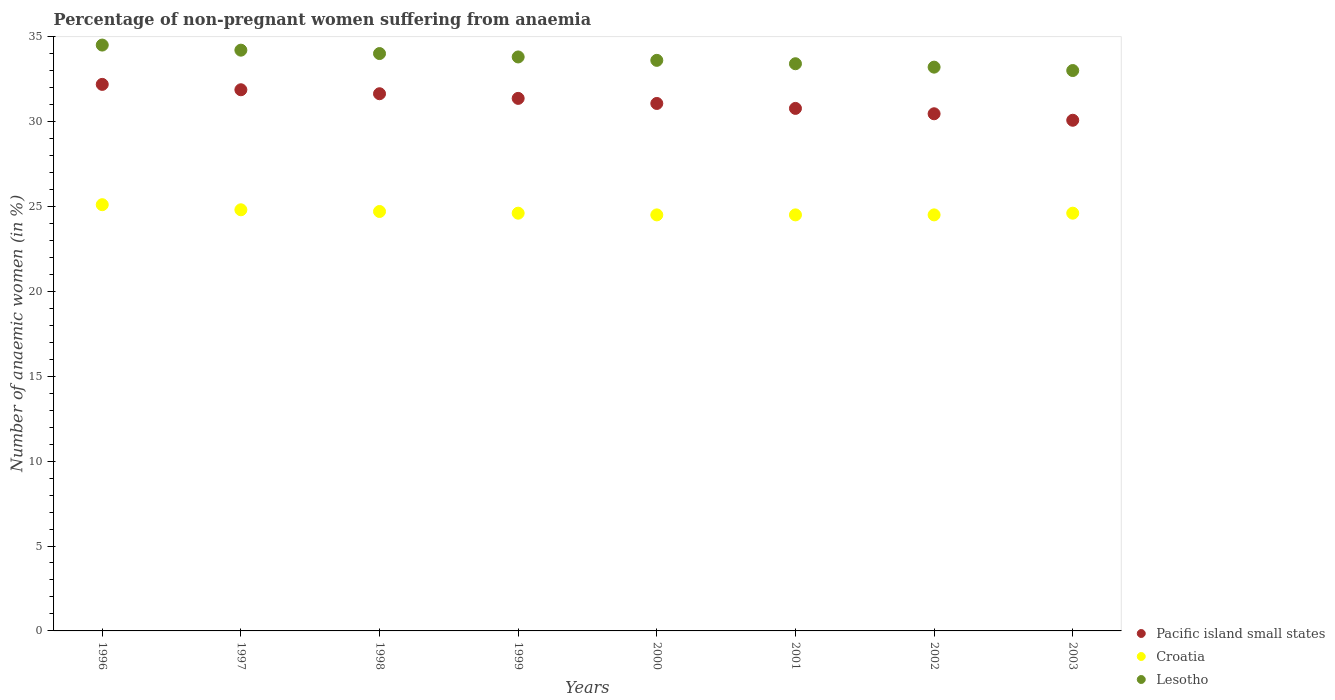Is the number of dotlines equal to the number of legend labels?
Provide a short and direct response. Yes. What is the percentage of non-pregnant women suffering from anaemia in Croatia in 2000?
Give a very brief answer. 24.5. Across all years, what is the maximum percentage of non-pregnant women suffering from anaemia in Pacific island small states?
Your response must be concise. 32.18. Across all years, what is the minimum percentage of non-pregnant women suffering from anaemia in Croatia?
Keep it short and to the point. 24.5. In which year was the percentage of non-pregnant women suffering from anaemia in Croatia minimum?
Offer a terse response. 2000. What is the total percentage of non-pregnant women suffering from anaemia in Croatia in the graph?
Make the answer very short. 197.3. What is the difference between the percentage of non-pregnant women suffering from anaemia in Croatia in 2003 and the percentage of non-pregnant women suffering from anaemia in Lesotho in 1997?
Provide a succinct answer. -9.6. What is the average percentage of non-pregnant women suffering from anaemia in Lesotho per year?
Keep it short and to the point. 33.71. In the year 2000, what is the difference between the percentage of non-pregnant women suffering from anaemia in Croatia and percentage of non-pregnant women suffering from anaemia in Pacific island small states?
Provide a short and direct response. -6.56. In how many years, is the percentage of non-pregnant women suffering from anaemia in Lesotho greater than 4 %?
Ensure brevity in your answer.  8. What is the ratio of the percentage of non-pregnant women suffering from anaemia in Croatia in 1996 to that in 2000?
Offer a terse response. 1.02. Is the percentage of non-pregnant women suffering from anaemia in Croatia in 1999 less than that in 2003?
Make the answer very short. No. What is the difference between the highest and the second highest percentage of non-pregnant women suffering from anaemia in Pacific island small states?
Keep it short and to the point. 0.32. What is the difference between the highest and the lowest percentage of non-pregnant women suffering from anaemia in Croatia?
Provide a short and direct response. 0.6. In how many years, is the percentage of non-pregnant women suffering from anaemia in Pacific island small states greater than the average percentage of non-pregnant women suffering from anaemia in Pacific island small states taken over all years?
Provide a short and direct response. 4. Is the sum of the percentage of non-pregnant women suffering from anaemia in Lesotho in 2001 and 2002 greater than the maximum percentage of non-pregnant women suffering from anaemia in Pacific island small states across all years?
Provide a succinct answer. Yes. Is it the case that in every year, the sum of the percentage of non-pregnant women suffering from anaemia in Lesotho and percentage of non-pregnant women suffering from anaemia in Pacific island small states  is greater than the percentage of non-pregnant women suffering from anaemia in Croatia?
Your answer should be compact. Yes. Is the percentage of non-pregnant women suffering from anaemia in Croatia strictly greater than the percentage of non-pregnant women suffering from anaemia in Pacific island small states over the years?
Provide a short and direct response. No. How many dotlines are there?
Ensure brevity in your answer.  3. How many years are there in the graph?
Your response must be concise. 8. Are the values on the major ticks of Y-axis written in scientific E-notation?
Your answer should be very brief. No. How many legend labels are there?
Offer a terse response. 3. What is the title of the graph?
Give a very brief answer. Percentage of non-pregnant women suffering from anaemia. Does "Guyana" appear as one of the legend labels in the graph?
Your answer should be compact. No. What is the label or title of the Y-axis?
Provide a succinct answer. Number of anaemic women (in %). What is the Number of anaemic women (in %) of Pacific island small states in 1996?
Offer a very short reply. 32.18. What is the Number of anaemic women (in %) in Croatia in 1996?
Offer a terse response. 25.1. What is the Number of anaemic women (in %) in Lesotho in 1996?
Ensure brevity in your answer.  34.5. What is the Number of anaemic women (in %) in Pacific island small states in 1997?
Ensure brevity in your answer.  31.87. What is the Number of anaemic women (in %) of Croatia in 1997?
Make the answer very short. 24.8. What is the Number of anaemic women (in %) of Lesotho in 1997?
Offer a terse response. 34.2. What is the Number of anaemic women (in %) in Pacific island small states in 1998?
Make the answer very short. 31.63. What is the Number of anaemic women (in %) of Croatia in 1998?
Provide a succinct answer. 24.7. What is the Number of anaemic women (in %) in Pacific island small states in 1999?
Offer a terse response. 31.36. What is the Number of anaemic women (in %) of Croatia in 1999?
Make the answer very short. 24.6. What is the Number of anaemic women (in %) in Lesotho in 1999?
Provide a short and direct response. 33.8. What is the Number of anaemic women (in %) in Pacific island small states in 2000?
Offer a very short reply. 31.06. What is the Number of anaemic women (in %) in Croatia in 2000?
Make the answer very short. 24.5. What is the Number of anaemic women (in %) of Lesotho in 2000?
Your answer should be compact. 33.6. What is the Number of anaemic women (in %) in Pacific island small states in 2001?
Offer a terse response. 30.77. What is the Number of anaemic women (in %) of Croatia in 2001?
Provide a succinct answer. 24.5. What is the Number of anaemic women (in %) in Lesotho in 2001?
Provide a succinct answer. 33.4. What is the Number of anaemic women (in %) of Pacific island small states in 2002?
Offer a terse response. 30.45. What is the Number of anaemic women (in %) in Croatia in 2002?
Your answer should be very brief. 24.5. What is the Number of anaemic women (in %) in Lesotho in 2002?
Give a very brief answer. 33.2. What is the Number of anaemic women (in %) in Pacific island small states in 2003?
Provide a succinct answer. 30.07. What is the Number of anaemic women (in %) in Croatia in 2003?
Your answer should be compact. 24.6. What is the Number of anaemic women (in %) in Lesotho in 2003?
Your answer should be compact. 33. Across all years, what is the maximum Number of anaemic women (in %) in Pacific island small states?
Your response must be concise. 32.18. Across all years, what is the maximum Number of anaemic women (in %) in Croatia?
Provide a succinct answer. 25.1. Across all years, what is the maximum Number of anaemic women (in %) in Lesotho?
Keep it short and to the point. 34.5. Across all years, what is the minimum Number of anaemic women (in %) of Pacific island small states?
Your answer should be compact. 30.07. Across all years, what is the minimum Number of anaemic women (in %) in Lesotho?
Provide a succinct answer. 33. What is the total Number of anaemic women (in %) of Pacific island small states in the graph?
Offer a very short reply. 249.4. What is the total Number of anaemic women (in %) of Croatia in the graph?
Your answer should be compact. 197.3. What is the total Number of anaemic women (in %) in Lesotho in the graph?
Ensure brevity in your answer.  269.7. What is the difference between the Number of anaemic women (in %) of Pacific island small states in 1996 and that in 1997?
Keep it short and to the point. 0.32. What is the difference between the Number of anaemic women (in %) of Croatia in 1996 and that in 1997?
Offer a very short reply. 0.3. What is the difference between the Number of anaemic women (in %) of Pacific island small states in 1996 and that in 1998?
Your answer should be compact. 0.55. What is the difference between the Number of anaemic women (in %) of Croatia in 1996 and that in 1998?
Your answer should be very brief. 0.4. What is the difference between the Number of anaemic women (in %) in Pacific island small states in 1996 and that in 1999?
Provide a short and direct response. 0.82. What is the difference between the Number of anaemic women (in %) in Lesotho in 1996 and that in 1999?
Provide a short and direct response. 0.7. What is the difference between the Number of anaemic women (in %) of Pacific island small states in 1996 and that in 2000?
Make the answer very short. 1.12. What is the difference between the Number of anaemic women (in %) in Pacific island small states in 1996 and that in 2001?
Your response must be concise. 1.41. What is the difference between the Number of anaemic women (in %) of Lesotho in 1996 and that in 2001?
Keep it short and to the point. 1.1. What is the difference between the Number of anaemic women (in %) of Pacific island small states in 1996 and that in 2002?
Offer a terse response. 1.73. What is the difference between the Number of anaemic women (in %) of Croatia in 1996 and that in 2002?
Ensure brevity in your answer.  0.6. What is the difference between the Number of anaemic women (in %) of Lesotho in 1996 and that in 2002?
Keep it short and to the point. 1.3. What is the difference between the Number of anaemic women (in %) in Pacific island small states in 1996 and that in 2003?
Offer a terse response. 2.11. What is the difference between the Number of anaemic women (in %) of Pacific island small states in 1997 and that in 1998?
Make the answer very short. 0.23. What is the difference between the Number of anaemic women (in %) of Pacific island small states in 1997 and that in 1999?
Ensure brevity in your answer.  0.51. What is the difference between the Number of anaemic women (in %) in Croatia in 1997 and that in 1999?
Your response must be concise. 0.2. What is the difference between the Number of anaemic women (in %) of Pacific island small states in 1997 and that in 2000?
Keep it short and to the point. 0.81. What is the difference between the Number of anaemic women (in %) in Croatia in 1997 and that in 2000?
Your answer should be very brief. 0.3. What is the difference between the Number of anaemic women (in %) in Lesotho in 1997 and that in 2000?
Provide a succinct answer. 0.6. What is the difference between the Number of anaemic women (in %) in Pacific island small states in 1997 and that in 2001?
Your answer should be very brief. 1.1. What is the difference between the Number of anaemic women (in %) in Croatia in 1997 and that in 2001?
Offer a terse response. 0.3. What is the difference between the Number of anaemic women (in %) in Lesotho in 1997 and that in 2001?
Keep it short and to the point. 0.8. What is the difference between the Number of anaemic women (in %) in Pacific island small states in 1997 and that in 2002?
Make the answer very short. 1.41. What is the difference between the Number of anaemic women (in %) of Lesotho in 1997 and that in 2002?
Keep it short and to the point. 1. What is the difference between the Number of anaemic women (in %) in Pacific island small states in 1997 and that in 2003?
Your answer should be very brief. 1.8. What is the difference between the Number of anaemic women (in %) of Croatia in 1997 and that in 2003?
Provide a succinct answer. 0.2. What is the difference between the Number of anaemic women (in %) of Pacific island small states in 1998 and that in 1999?
Make the answer very short. 0.27. What is the difference between the Number of anaemic women (in %) in Pacific island small states in 1998 and that in 2000?
Your response must be concise. 0.57. What is the difference between the Number of anaemic women (in %) in Lesotho in 1998 and that in 2000?
Your response must be concise. 0.4. What is the difference between the Number of anaemic women (in %) in Pacific island small states in 1998 and that in 2001?
Offer a very short reply. 0.86. What is the difference between the Number of anaemic women (in %) of Pacific island small states in 1998 and that in 2002?
Offer a terse response. 1.18. What is the difference between the Number of anaemic women (in %) in Croatia in 1998 and that in 2002?
Your response must be concise. 0.2. What is the difference between the Number of anaemic women (in %) of Pacific island small states in 1998 and that in 2003?
Provide a succinct answer. 1.56. What is the difference between the Number of anaemic women (in %) of Pacific island small states in 1999 and that in 2000?
Provide a short and direct response. 0.3. What is the difference between the Number of anaemic women (in %) in Croatia in 1999 and that in 2000?
Provide a short and direct response. 0.1. What is the difference between the Number of anaemic women (in %) of Pacific island small states in 1999 and that in 2001?
Give a very brief answer. 0.59. What is the difference between the Number of anaemic women (in %) in Croatia in 1999 and that in 2001?
Offer a very short reply. 0.1. What is the difference between the Number of anaemic women (in %) of Pacific island small states in 1999 and that in 2002?
Offer a terse response. 0.91. What is the difference between the Number of anaemic women (in %) in Lesotho in 1999 and that in 2002?
Give a very brief answer. 0.6. What is the difference between the Number of anaemic women (in %) in Pacific island small states in 1999 and that in 2003?
Offer a terse response. 1.29. What is the difference between the Number of anaemic women (in %) of Croatia in 1999 and that in 2003?
Offer a very short reply. 0. What is the difference between the Number of anaemic women (in %) in Pacific island small states in 2000 and that in 2001?
Your answer should be compact. 0.29. What is the difference between the Number of anaemic women (in %) in Pacific island small states in 2000 and that in 2002?
Offer a very short reply. 0.61. What is the difference between the Number of anaemic women (in %) of Croatia in 2000 and that in 2002?
Offer a terse response. 0. What is the difference between the Number of anaemic women (in %) in Croatia in 2000 and that in 2003?
Your answer should be compact. -0.1. What is the difference between the Number of anaemic women (in %) in Pacific island small states in 2001 and that in 2002?
Keep it short and to the point. 0.32. What is the difference between the Number of anaemic women (in %) of Lesotho in 2001 and that in 2002?
Make the answer very short. 0.2. What is the difference between the Number of anaemic women (in %) in Pacific island small states in 2001 and that in 2003?
Ensure brevity in your answer.  0.7. What is the difference between the Number of anaemic women (in %) in Croatia in 2001 and that in 2003?
Offer a terse response. -0.1. What is the difference between the Number of anaemic women (in %) of Pacific island small states in 2002 and that in 2003?
Provide a succinct answer. 0.38. What is the difference between the Number of anaemic women (in %) of Croatia in 2002 and that in 2003?
Give a very brief answer. -0.1. What is the difference between the Number of anaemic women (in %) in Lesotho in 2002 and that in 2003?
Keep it short and to the point. 0.2. What is the difference between the Number of anaemic women (in %) in Pacific island small states in 1996 and the Number of anaemic women (in %) in Croatia in 1997?
Ensure brevity in your answer.  7.38. What is the difference between the Number of anaemic women (in %) of Pacific island small states in 1996 and the Number of anaemic women (in %) of Lesotho in 1997?
Offer a very short reply. -2.02. What is the difference between the Number of anaemic women (in %) in Pacific island small states in 1996 and the Number of anaemic women (in %) in Croatia in 1998?
Your answer should be very brief. 7.48. What is the difference between the Number of anaemic women (in %) in Pacific island small states in 1996 and the Number of anaemic women (in %) in Lesotho in 1998?
Provide a short and direct response. -1.82. What is the difference between the Number of anaemic women (in %) of Croatia in 1996 and the Number of anaemic women (in %) of Lesotho in 1998?
Offer a terse response. -8.9. What is the difference between the Number of anaemic women (in %) of Pacific island small states in 1996 and the Number of anaemic women (in %) of Croatia in 1999?
Your response must be concise. 7.58. What is the difference between the Number of anaemic women (in %) in Pacific island small states in 1996 and the Number of anaemic women (in %) in Lesotho in 1999?
Provide a short and direct response. -1.62. What is the difference between the Number of anaemic women (in %) of Croatia in 1996 and the Number of anaemic women (in %) of Lesotho in 1999?
Offer a terse response. -8.7. What is the difference between the Number of anaemic women (in %) of Pacific island small states in 1996 and the Number of anaemic women (in %) of Croatia in 2000?
Provide a short and direct response. 7.68. What is the difference between the Number of anaemic women (in %) in Pacific island small states in 1996 and the Number of anaemic women (in %) in Lesotho in 2000?
Give a very brief answer. -1.42. What is the difference between the Number of anaemic women (in %) in Croatia in 1996 and the Number of anaemic women (in %) in Lesotho in 2000?
Ensure brevity in your answer.  -8.5. What is the difference between the Number of anaemic women (in %) of Pacific island small states in 1996 and the Number of anaemic women (in %) of Croatia in 2001?
Give a very brief answer. 7.68. What is the difference between the Number of anaemic women (in %) in Pacific island small states in 1996 and the Number of anaemic women (in %) in Lesotho in 2001?
Give a very brief answer. -1.22. What is the difference between the Number of anaemic women (in %) of Pacific island small states in 1996 and the Number of anaemic women (in %) of Croatia in 2002?
Your answer should be compact. 7.68. What is the difference between the Number of anaemic women (in %) in Pacific island small states in 1996 and the Number of anaemic women (in %) in Lesotho in 2002?
Offer a terse response. -1.02. What is the difference between the Number of anaemic women (in %) in Croatia in 1996 and the Number of anaemic women (in %) in Lesotho in 2002?
Provide a short and direct response. -8.1. What is the difference between the Number of anaemic women (in %) of Pacific island small states in 1996 and the Number of anaemic women (in %) of Croatia in 2003?
Your answer should be very brief. 7.58. What is the difference between the Number of anaemic women (in %) in Pacific island small states in 1996 and the Number of anaemic women (in %) in Lesotho in 2003?
Make the answer very short. -0.82. What is the difference between the Number of anaemic women (in %) of Pacific island small states in 1997 and the Number of anaemic women (in %) of Croatia in 1998?
Ensure brevity in your answer.  7.17. What is the difference between the Number of anaemic women (in %) in Pacific island small states in 1997 and the Number of anaemic women (in %) in Lesotho in 1998?
Your response must be concise. -2.13. What is the difference between the Number of anaemic women (in %) of Croatia in 1997 and the Number of anaemic women (in %) of Lesotho in 1998?
Offer a very short reply. -9.2. What is the difference between the Number of anaemic women (in %) in Pacific island small states in 1997 and the Number of anaemic women (in %) in Croatia in 1999?
Offer a very short reply. 7.27. What is the difference between the Number of anaemic women (in %) of Pacific island small states in 1997 and the Number of anaemic women (in %) of Lesotho in 1999?
Ensure brevity in your answer.  -1.93. What is the difference between the Number of anaemic women (in %) of Croatia in 1997 and the Number of anaemic women (in %) of Lesotho in 1999?
Keep it short and to the point. -9. What is the difference between the Number of anaemic women (in %) in Pacific island small states in 1997 and the Number of anaemic women (in %) in Croatia in 2000?
Provide a succinct answer. 7.37. What is the difference between the Number of anaemic women (in %) in Pacific island small states in 1997 and the Number of anaemic women (in %) in Lesotho in 2000?
Provide a succinct answer. -1.73. What is the difference between the Number of anaemic women (in %) of Pacific island small states in 1997 and the Number of anaemic women (in %) of Croatia in 2001?
Provide a short and direct response. 7.37. What is the difference between the Number of anaemic women (in %) in Pacific island small states in 1997 and the Number of anaemic women (in %) in Lesotho in 2001?
Offer a very short reply. -1.53. What is the difference between the Number of anaemic women (in %) in Pacific island small states in 1997 and the Number of anaemic women (in %) in Croatia in 2002?
Keep it short and to the point. 7.37. What is the difference between the Number of anaemic women (in %) of Pacific island small states in 1997 and the Number of anaemic women (in %) of Lesotho in 2002?
Provide a succinct answer. -1.33. What is the difference between the Number of anaemic women (in %) of Pacific island small states in 1997 and the Number of anaemic women (in %) of Croatia in 2003?
Offer a very short reply. 7.27. What is the difference between the Number of anaemic women (in %) in Pacific island small states in 1997 and the Number of anaemic women (in %) in Lesotho in 2003?
Your answer should be very brief. -1.13. What is the difference between the Number of anaemic women (in %) in Croatia in 1997 and the Number of anaemic women (in %) in Lesotho in 2003?
Make the answer very short. -8.2. What is the difference between the Number of anaemic women (in %) of Pacific island small states in 1998 and the Number of anaemic women (in %) of Croatia in 1999?
Offer a very short reply. 7.03. What is the difference between the Number of anaemic women (in %) of Pacific island small states in 1998 and the Number of anaemic women (in %) of Lesotho in 1999?
Your answer should be compact. -2.17. What is the difference between the Number of anaemic women (in %) of Croatia in 1998 and the Number of anaemic women (in %) of Lesotho in 1999?
Your answer should be compact. -9.1. What is the difference between the Number of anaemic women (in %) in Pacific island small states in 1998 and the Number of anaemic women (in %) in Croatia in 2000?
Provide a succinct answer. 7.13. What is the difference between the Number of anaemic women (in %) in Pacific island small states in 1998 and the Number of anaemic women (in %) in Lesotho in 2000?
Give a very brief answer. -1.97. What is the difference between the Number of anaemic women (in %) of Pacific island small states in 1998 and the Number of anaemic women (in %) of Croatia in 2001?
Your answer should be very brief. 7.13. What is the difference between the Number of anaemic women (in %) in Pacific island small states in 1998 and the Number of anaemic women (in %) in Lesotho in 2001?
Offer a very short reply. -1.77. What is the difference between the Number of anaemic women (in %) of Pacific island small states in 1998 and the Number of anaemic women (in %) of Croatia in 2002?
Provide a succinct answer. 7.13. What is the difference between the Number of anaemic women (in %) of Pacific island small states in 1998 and the Number of anaemic women (in %) of Lesotho in 2002?
Give a very brief answer. -1.57. What is the difference between the Number of anaemic women (in %) of Croatia in 1998 and the Number of anaemic women (in %) of Lesotho in 2002?
Your answer should be very brief. -8.5. What is the difference between the Number of anaemic women (in %) of Pacific island small states in 1998 and the Number of anaemic women (in %) of Croatia in 2003?
Ensure brevity in your answer.  7.03. What is the difference between the Number of anaemic women (in %) of Pacific island small states in 1998 and the Number of anaemic women (in %) of Lesotho in 2003?
Provide a short and direct response. -1.37. What is the difference between the Number of anaemic women (in %) of Croatia in 1998 and the Number of anaemic women (in %) of Lesotho in 2003?
Your response must be concise. -8.3. What is the difference between the Number of anaemic women (in %) of Pacific island small states in 1999 and the Number of anaemic women (in %) of Croatia in 2000?
Provide a succinct answer. 6.86. What is the difference between the Number of anaemic women (in %) of Pacific island small states in 1999 and the Number of anaemic women (in %) of Lesotho in 2000?
Your answer should be compact. -2.24. What is the difference between the Number of anaemic women (in %) of Pacific island small states in 1999 and the Number of anaemic women (in %) of Croatia in 2001?
Provide a short and direct response. 6.86. What is the difference between the Number of anaemic women (in %) of Pacific island small states in 1999 and the Number of anaemic women (in %) of Lesotho in 2001?
Provide a succinct answer. -2.04. What is the difference between the Number of anaemic women (in %) in Croatia in 1999 and the Number of anaemic women (in %) in Lesotho in 2001?
Provide a succinct answer. -8.8. What is the difference between the Number of anaemic women (in %) of Pacific island small states in 1999 and the Number of anaemic women (in %) of Croatia in 2002?
Offer a terse response. 6.86. What is the difference between the Number of anaemic women (in %) of Pacific island small states in 1999 and the Number of anaemic women (in %) of Lesotho in 2002?
Make the answer very short. -1.84. What is the difference between the Number of anaemic women (in %) of Croatia in 1999 and the Number of anaemic women (in %) of Lesotho in 2002?
Ensure brevity in your answer.  -8.6. What is the difference between the Number of anaemic women (in %) of Pacific island small states in 1999 and the Number of anaemic women (in %) of Croatia in 2003?
Offer a very short reply. 6.76. What is the difference between the Number of anaemic women (in %) of Pacific island small states in 1999 and the Number of anaemic women (in %) of Lesotho in 2003?
Your answer should be compact. -1.64. What is the difference between the Number of anaemic women (in %) of Pacific island small states in 2000 and the Number of anaemic women (in %) of Croatia in 2001?
Make the answer very short. 6.56. What is the difference between the Number of anaemic women (in %) of Pacific island small states in 2000 and the Number of anaemic women (in %) of Lesotho in 2001?
Provide a short and direct response. -2.34. What is the difference between the Number of anaemic women (in %) of Pacific island small states in 2000 and the Number of anaemic women (in %) of Croatia in 2002?
Your answer should be very brief. 6.56. What is the difference between the Number of anaemic women (in %) of Pacific island small states in 2000 and the Number of anaemic women (in %) of Lesotho in 2002?
Ensure brevity in your answer.  -2.14. What is the difference between the Number of anaemic women (in %) in Pacific island small states in 2000 and the Number of anaemic women (in %) in Croatia in 2003?
Make the answer very short. 6.46. What is the difference between the Number of anaemic women (in %) of Pacific island small states in 2000 and the Number of anaemic women (in %) of Lesotho in 2003?
Ensure brevity in your answer.  -1.94. What is the difference between the Number of anaemic women (in %) of Pacific island small states in 2001 and the Number of anaemic women (in %) of Croatia in 2002?
Ensure brevity in your answer.  6.27. What is the difference between the Number of anaemic women (in %) in Pacific island small states in 2001 and the Number of anaemic women (in %) in Lesotho in 2002?
Give a very brief answer. -2.43. What is the difference between the Number of anaemic women (in %) of Pacific island small states in 2001 and the Number of anaemic women (in %) of Croatia in 2003?
Your answer should be very brief. 6.17. What is the difference between the Number of anaemic women (in %) in Pacific island small states in 2001 and the Number of anaemic women (in %) in Lesotho in 2003?
Ensure brevity in your answer.  -2.23. What is the difference between the Number of anaemic women (in %) of Pacific island small states in 2002 and the Number of anaemic women (in %) of Croatia in 2003?
Your answer should be compact. 5.85. What is the difference between the Number of anaemic women (in %) in Pacific island small states in 2002 and the Number of anaemic women (in %) in Lesotho in 2003?
Your answer should be compact. -2.55. What is the average Number of anaemic women (in %) in Pacific island small states per year?
Provide a succinct answer. 31.18. What is the average Number of anaemic women (in %) of Croatia per year?
Offer a very short reply. 24.66. What is the average Number of anaemic women (in %) in Lesotho per year?
Your response must be concise. 33.71. In the year 1996, what is the difference between the Number of anaemic women (in %) in Pacific island small states and Number of anaemic women (in %) in Croatia?
Make the answer very short. 7.08. In the year 1996, what is the difference between the Number of anaemic women (in %) of Pacific island small states and Number of anaemic women (in %) of Lesotho?
Ensure brevity in your answer.  -2.32. In the year 1996, what is the difference between the Number of anaemic women (in %) of Croatia and Number of anaemic women (in %) of Lesotho?
Your answer should be very brief. -9.4. In the year 1997, what is the difference between the Number of anaemic women (in %) in Pacific island small states and Number of anaemic women (in %) in Croatia?
Your answer should be very brief. 7.07. In the year 1997, what is the difference between the Number of anaemic women (in %) of Pacific island small states and Number of anaemic women (in %) of Lesotho?
Offer a terse response. -2.33. In the year 1998, what is the difference between the Number of anaemic women (in %) in Pacific island small states and Number of anaemic women (in %) in Croatia?
Ensure brevity in your answer.  6.93. In the year 1998, what is the difference between the Number of anaemic women (in %) in Pacific island small states and Number of anaemic women (in %) in Lesotho?
Make the answer very short. -2.37. In the year 1999, what is the difference between the Number of anaemic women (in %) in Pacific island small states and Number of anaemic women (in %) in Croatia?
Your response must be concise. 6.76. In the year 1999, what is the difference between the Number of anaemic women (in %) in Pacific island small states and Number of anaemic women (in %) in Lesotho?
Offer a very short reply. -2.44. In the year 1999, what is the difference between the Number of anaemic women (in %) of Croatia and Number of anaemic women (in %) of Lesotho?
Your answer should be very brief. -9.2. In the year 2000, what is the difference between the Number of anaemic women (in %) in Pacific island small states and Number of anaemic women (in %) in Croatia?
Your answer should be compact. 6.56. In the year 2000, what is the difference between the Number of anaemic women (in %) of Pacific island small states and Number of anaemic women (in %) of Lesotho?
Ensure brevity in your answer.  -2.54. In the year 2000, what is the difference between the Number of anaemic women (in %) in Croatia and Number of anaemic women (in %) in Lesotho?
Offer a terse response. -9.1. In the year 2001, what is the difference between the Number of anaemic women (in %) of Pacific island small states and Number of anaemic women (in %) of Croatia?
Give a very brief answer. 6.27. In the year 2001, what is the difference between the Number of anaemic women (in %) of Pacific island small states and Number of anaemic women (in %) of Lesotho?
Ensure brevity in your answer.  -2.63. In the year 2002, what is the difference between the Number of anaemic women (in %) in Pacific island small states and Number of anaemic women (in %) in Croatia?
Keep it short and to the point. 5.95. In the year 2002, what is the difference between the Number of anaemic women (in %) in Pacific island small states and Number of anaemic women (in %) in Lesotho?
Your response must be concise. -2.75. In the year 2002, what is the difference between the Number of anaemic women (in %) of Croatia and Number of anaemic women (in %) of Lesotho?
Offer a very short reply. -8.7. In the year 2003, what is the difference between the Number of anaemic women (in %) of Pacific island small states and Number of anaemic women (in %) of Croatia?
Give a very brief answer. 5.47. In the year 2003, what is the difference between the Number of anaemic women (in %) of Pacific island small states and Number of anaemic women (in %) of Lesotho?
Your answer should be very brief. -2.93. What is the ratio of the Number of anaemic women (in %) of Pacific island small states in 1996 to that in 1997?
Offer a terse response. 1.01. What is the ratio of the Number of anaemic women (in %) of Croatia in 1996 to that in 1997?
Make the answer very short. 1.01. What is the ratio of the Number of anaemic women (in %) of Lesotho in 1996 to that in 1997?
Make the answer very short. 1.01. What is the ratio of the Number of anaemic women (in %) in Pacific island small states in 1996 to that in 1998?
Your answer should be very brief. 1.02. What is the ratio of the Number of anaemic women (in %) in Croatia in 1996 to that in 1998?
Ensure brevity in your answer.  1.02. What is the ratio of the Number of anaemic women (in %) of Lesotho in 1996 to that in 1998?
Offer a very short reply. 1.01. What is the ratio of the Number of anaemic women (in %) in Pacific island small states in 1996 to that in 1999?
Provide a short and direct response. 1.03. What is the ratio of the Number of anaemic women (in %) of Croatia in 1996 to that in 1999?
Your response must be concise. 1.02. What is the ratio of the Number of anaemic women (in %) in Lesotho in 1996 to that in 1999?
Offer a very short reply. 1.02. What is the ratio of the Number of anaemic women (in %) in Pacific island small states in 1996 to that in 2000?
Provide a short and direct response. 1.04. What is the ratio of the Number of anaemic women (in %) in Croatia in 1996 to that in 2000?
Your response must be concise. 1.02. What is the ratio of the Number of anaemic women (in %) in Lesotho in 1996 to that in 2000?
Your response must be concise. 1.03. What is the ratio of the Number of anaemic women (in %) of Pacific island small states in 1996 to that in 2001?
Offer a very short reply. 1.05. What is the ratio of the Number of anaemic women (in %) of Croatia in 1996 to that in 2001?
Keep it short and to the point. 1.02. What is the ratio of the Number of anaemic women (in %) of Lesotho in 1996 to that in 2001?
Give a very brief answer. 1.03. What is the ratio of the Number of anaemic women (in %) of Pacific island small states in 1996 to that in 2002?
Give a very brief answer. 1.06. What is the ratio of the Number of anaemic women (in %) in Croatia in 1996 to that in 2002?
Offer a very short reply. 1.02. What is the ratio of the Number of anaemic women (in %) of Lesotho in 1996 to that in 2002?
Offer a very short reply. 1.04. What is the ratio of the Number of anaemic women (in %) of Pacific island small states in 1996 to that in 2003?
Give a very brief answer. 1.07. What is the ratio of the Number of anaemic women (in %) in Croatia in 1996 to that in 2003?
Your response must be concise. 1.02. What is the ratio of the Number of anaemic women (in %) in Lesotho in 1996 to that in 2003?
Make the answer very short. 1.05. What is the ratio of the Number of anaemic women (in %) of Pacific island small states in 1997 to that in 1998?
Offer a terse response. 1.01. What is the ratio of the Number of anaemic women (in %) in Lesotho in 1997 to that in 1998?
Offer a very short reply. 1.01. What is the ratio of the Number of anaemic women (in %) in Pacific island small states in 1997 to that in 1999?
Give a very brief answer. 1.02. What is the ratio of the Number of anaemic women (in %) of Lesotho in 1997 to that in 1999?
Give a very brief answer. 1.01. What is the ratio of the Number of anaemic women (in %) of Croatia in 1997 to that in 2000?
Your answer should be very brief. 1.01. What is the ratio of the Number of anaemic women (in %) of Lesotho in 1997 to that in 2000?
Your answer should be compact. 1.02. What is the ratio of the Number of anaemic women (in %) of Pacific island small states in 1997 to that in 2001?
Keep it short and to the point. 1.04. What is the ratio of the Number of anaemic women (in %) in Croatia in 1997 to that in 2001?
Give a very brief answer. 1.01. What is the ratio of the Number of anaemic women (in %) of Lesotho in 1997 to that in 2001?
Make the answer very short. 1.02. What is the ratio of the Number of anaemic women (in %) in Pacific island small states in 1997 to that in 2002?
Give a very brief answer. 1.05. What is the ratio of the Number of anaemic women (in %) of Croatia in 1997 to that in 2002?
Offer a very short reply. 1.01. What is the ratio of the Number of anaemic women (in %) in Lesotho in 1997 to that in 2002?
Provide a succinct answer. 1.03. What is the ratio of the Number of anaemic women (in %) of Pacific island small states in 1997 to that in 2003?
Make the answer very short. 1.06. What is the ratio of the Number of anaemic women (in %) of Croatia in 1997 to that in 2003?
Offer a terse response. 1.01. What is the ratio of the Number of anaemic women (in %) of Lesotho in 1997 to that in 2003?
Your answer should be compact. 1.04. What is the ratio of the Number of anaemic women (in %) of Pacific island small states in 1998 to that in 1999?
Make the answer very short. 1.01. What is the ratio of the Number of anaemic women (in %) of Lesotho in 1998 to that in 1999?
Your answer should be very brief. 1.01. What is the ratio of the Number of anaemic women (in %) in Pacific island small states in 1998 to that in 2000?
Your answer should be compact. 1.02. What is the ratio of the Number of anaemic women (in %) of Croatia in 1998 to that in 2000?
Provide a short and direct response. 1.01. What is the ratio of the Number of anaemic women (in %) of Lesotho in 1998 to that in 2000?
Provide a short and direct response. 1.01. What is the ratio of the Number of anaemic women (in %) in Pacific island small states in 1998 to that in 2001?
Make the answer very short. 1.03. What is the ratio of the Number of anaemic women (in %) in Croatia in 1998 to that in 2001?
Your answer should be very brief. 1.01. What is the ratio of the Number of anaemic women (in %) in Lesotho in 1998 to that in 2001?
Offer a very short reply. 1.02. What is the ratio of the Number of anaemic women (in %) of Pacific island small states in 1998 to that in 2002?
Your response must be concise. 1.04. What is the ratio of the Number of anaemic women (in %) of Croatia in 1998 to that in 2002?
Provide a succinct answer. 1.01. What is the ratio of the Number of anaemic women (in %) of Lesotho in 1998 to that in 2002?
Provide a short and direct response. 1.02. What is the ratio of the Number of anaemic women (in %) of Pacific island small states in 1998 to that in 2003?
Provide a short and direct response. 1.05. What is the ratio of the Number of anaemic women (in %) in Lesotho in 1998 to that in 2003?
Your answer should be very brief. 1.03. What is the ratio of the Number of anaemic women (in %) of Pacific island small states in 1999 to that in 2000?
Your answer should be very brief. 1.01. What is the ratio of the Number of anaemic women (in %) in Croatia in 1999 to that in 2000?
Offer a very short reply. 1. What is the ratio of the Number of anaemic women (in %) of Lesotho in 1999 to that in 2000?
Offer a terse response. 1.01. What is the ratio of the Number of anaemic women (in %) in Pacific island small states in 1999 to that in 2001?
Ensure brevity in your answer.  1.02. What is the ratio of the Number of anaemic women (in %) of Croatia in 1999 to that in 2001?
Your answer should be very brief. 1. What is the ratio of the Number of anaemic women (in %) in Pacific island small states in 1999 to that in 2002?
Offer a very short reply. 1.03. What is the ratio of the Number of anaemic women (in %) in Croatia in 1999 to that in 2002?
Offer a very short reply. 1. What is the ratio of the Number of anaemic women (in %) of Lesotho in 1999 to that in 2002?
Your response must be concise. 1.02. What is the ratio of the Number of anaemic women (in %) in Pacific island small states in 1999 to that in 2003?
Your response must be concise. 1.04. What is the ratio of the Number of anaemic women (in %) of Croatia in 1999 to that in 2003?
Your answer should be very brief. 1. What is the ratio of the Number of anaemic women (in %) of Lesotho in 1999 to that in 2003?
Your answer should be very brief. 1.02. What is the ratio of the Number of anaemic women (in %) of Pacific island small states in 2000 to that in 2001?
Your answer should be very brief. 1.01. What is the ratio of the Number of anaemic women (in %) of Pacific island small states in 2000 to that in 2002?
Your answer should be compact. 1.02. What is the ratio of the Number of anaemic women (in %) in Croatia in 2000 to that in 2002?
Provide a short and direct response. 1. What is the ratio of the Number of anaemic women (in %) of Lesotho in 2000 to that in 2002?
Your response must be concise. 1.01. What is the ratio of the Number of anaemic women (in %) in Pacific island small states in 2000 to that in 2003?
Provide a succinct answer. 1.03. What is the ratio of the Number of anaemic women (in %) of Croatia in 2000 to that in 2003?
Your response must be concise. 1. What is the ratio of the Number of anaemic women (in %) in Lesotho in 2000 to that in 2003?
Make the answer very short. 1.02. What is the ratio of the Number of anaemic women (in %) in Pacific island small states in 2001 to that in 2002?
Your answer should be compact. 1.01. What is the ratio of the Number of anaemic women (in %) of Croatia in 2001 to that in 2002?
Provide a short and direct response. 1. What is the ratio of the Number of anaemic women (in %) of Pacific island small states in 2001 to that in 2003?
Keep it short and to the point. 1.02. What is the ratio of the Number of anaemic women (in %) of Lesotho in 2001 to that in 2003?
Give a very brief answer. 1.01. What is the ratio of the Number of anaemic women (in %) in Pacific island small states in 2002 to that in 2003?
Your answer should be compact. 1.01. What is the ratio of the Number of anaemic women (in %) of Lesotho in 2002 to that in 2003?
Provide a succinct answer. 1.01. What is the difference between the highest and the second highest Number of anaemic women (in %) of Pacific island small states?
Your answer should be compact. 0.32. What is the difference between the highest and the second highest Number of anaemic women (in %) of Croatia?
Your answer should be compact. 0.3. What is the difference between the highest and the second highest Number of anaemic women (in %) in Lesotho?
Give a very brief answer. 0.3. What is the difference between the highest and the lowest Number of anaemic women (in %) in Pacific island small states?
Provide a short and direct response. 2.11. What is the difference between the highest and the lowest Number of anaemic women (in %) of Croatia?
Offer a terse response. 0.6. What is the difference between the highest and the lowest Number of anaemic women (in %) in Lesotho?
Offer a terse response. 1.5. 